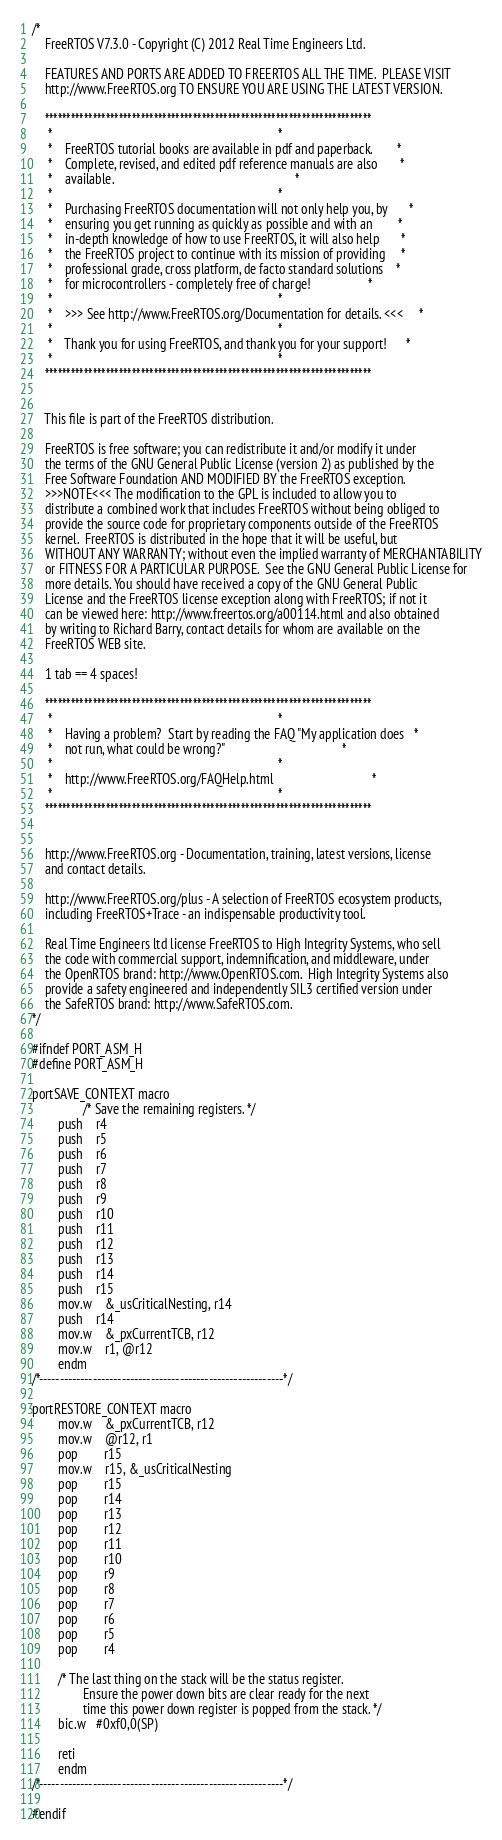Convert code to text. <code><loc_0><loc_0><loc_500><loc_500><_C_>/*
    FreeRTOS V7.3.0 - Copyright (C) 2012 Real Time Engineers Ltd.

    FEATURES AND PORTS ARE ADDED TO FREERTOS ALL THE TIME.  PLEASE VISIT 
    http://www.FreeRTOS.org TO ENSURE YOU ARE USING THE LATEST VERSION.

    ***************************************************************************
     *                                                                       *
     *    FreeRTOS tutorial books are available in pdf and paperback.        *
     *    Complete, revised, and edited pdf reference manuals are also       *
     *    available.                                                         *
     *                                                                       *
     *    Purchasing FreeRTOS documentation will not only help you, by       *
     *    ensuring you get running as quickly as possible and with an        *
     *    in-depth knowledge of how to use FreeRTOS, it will also help       *
     *    the FreeRTOS project to continue with its mission of providing     *
     *    professional grade, cross platform, de facto standard solutions    *
     *    for microcontrollers - completely free of charge!                  *
     *                                                                       *
     *    >>> See http://www.FreeRTOS.org/Documentation for details. <<<     *
     *                                                                       *
     *    Thank you for using FreeRTOS, and thank you for your support!      *
     *                                                                       *
    ***************************************************************************


    This file is part of the FreeRTOS distribution.

    FreeRTOS is free software; you can redistribute it and/or modify it under
    the terms of the GNU General Public License (version 2) as published by the
    Free Software Foundation AND MODIFIED BY the FreeRTOS exception.
    >>>NOTE<<< The modification to the GPL is included to allow you to
    distribute a combined work that includes FreeRTOS without being obliged to
    provide the source code for proprietary components outside of the FreeRTOS
    kernel.  FreeRTOS is distributed in the hope that it will be useful, but
    WITHOUT ANY WARRANTY; without even the implied warranty of MERCHANTABILITY
    or FITNESS FOR A PARTICULAR PURPOSE.  See the GNU General Public License for
    more details. You should have received a copy of the GNU General Public
    License and the FreeRTOS license exception along with FreeRTOS; if not it
    can be viewed here: http://www.freertos.org/a00114.html and also obtained
    by writing to Richard Barry, contact details for whom are available on the
    FreeRTOS WEB site.

    1 tab == 4 spaces!
    
    ***************************************************************************
     *                                                                       *
     *    Having a problem?  Start by reading the FAQ "My application does   *
     *    not run, what could be wrong?"                                     *
     *                                                                       *
     *    http://www.FreeRTOS.org/FAQHelp.html                               *
     *                                                                       *
    ***************************************************************************

    
    http://www.FreeRTOS.org - Documentation, training, latest versions, license 
    and contact details.  
    
    http://www.FreeRTOS.org/plus - A selection of FreeRTOS ecosystem products,
    including FreeRTOS+Trace - an indispensable productivity tool.

    Real Time Engineers ltd license FreeRTOS to High Integrity Systems, who sell 
    the code with commercial support, indemnification, and middleware, under 
    the OpenRTOS brand: http://www.OpenRTOS.com.  High Integrity Systems also
    provide a safety engineered and independently SIL3 certified version under 
    the SafeRTOS brand: http://www.SafeRTOS.com.
*/

#ifndef PORT_ASM_H
#define PORT_ASM_H

portSAVE_CONTEXT macro
                /* Save the remaining registers. */
		push	r4
		push	r5
		push	r6
		push	r7
		push	r8
		push	r9
		push	r10
		push	r11
		push	r12
		push	r13
		push	r14
		push	r15
		mov.w	&_usCriticalNesting, r14
		push	r14
		mov.w	&_pxCurrentTCB, r12
		mov.w	r1, @r12
		endm
/*-----------------------------------------------------------*/
		
portRESTORE_CONTEXT macro
		mov.w	&_pxCurrentTCB, r12
		mov.w	@r12, r1
		pop		r15
		mov.w	r15, &_usCriticalNesting
		pop		r15
		pop		r14
		pop		r13
		pop		r12
		pop		r11
		pop		r10
		pop		r9
		pop		r8
		pop		r7
		pop		r6
		pop		r5
		pop		r4

		/* The last thing on the stack will be the status register.
                Ensure the power down bits are clear ready for the next
                time this power down register is popped from the stack. */
		bic.w   #0xf0,0(SP)

		reti
		endm
/*-----------------------------------------------------------*/

#endif

</code> 